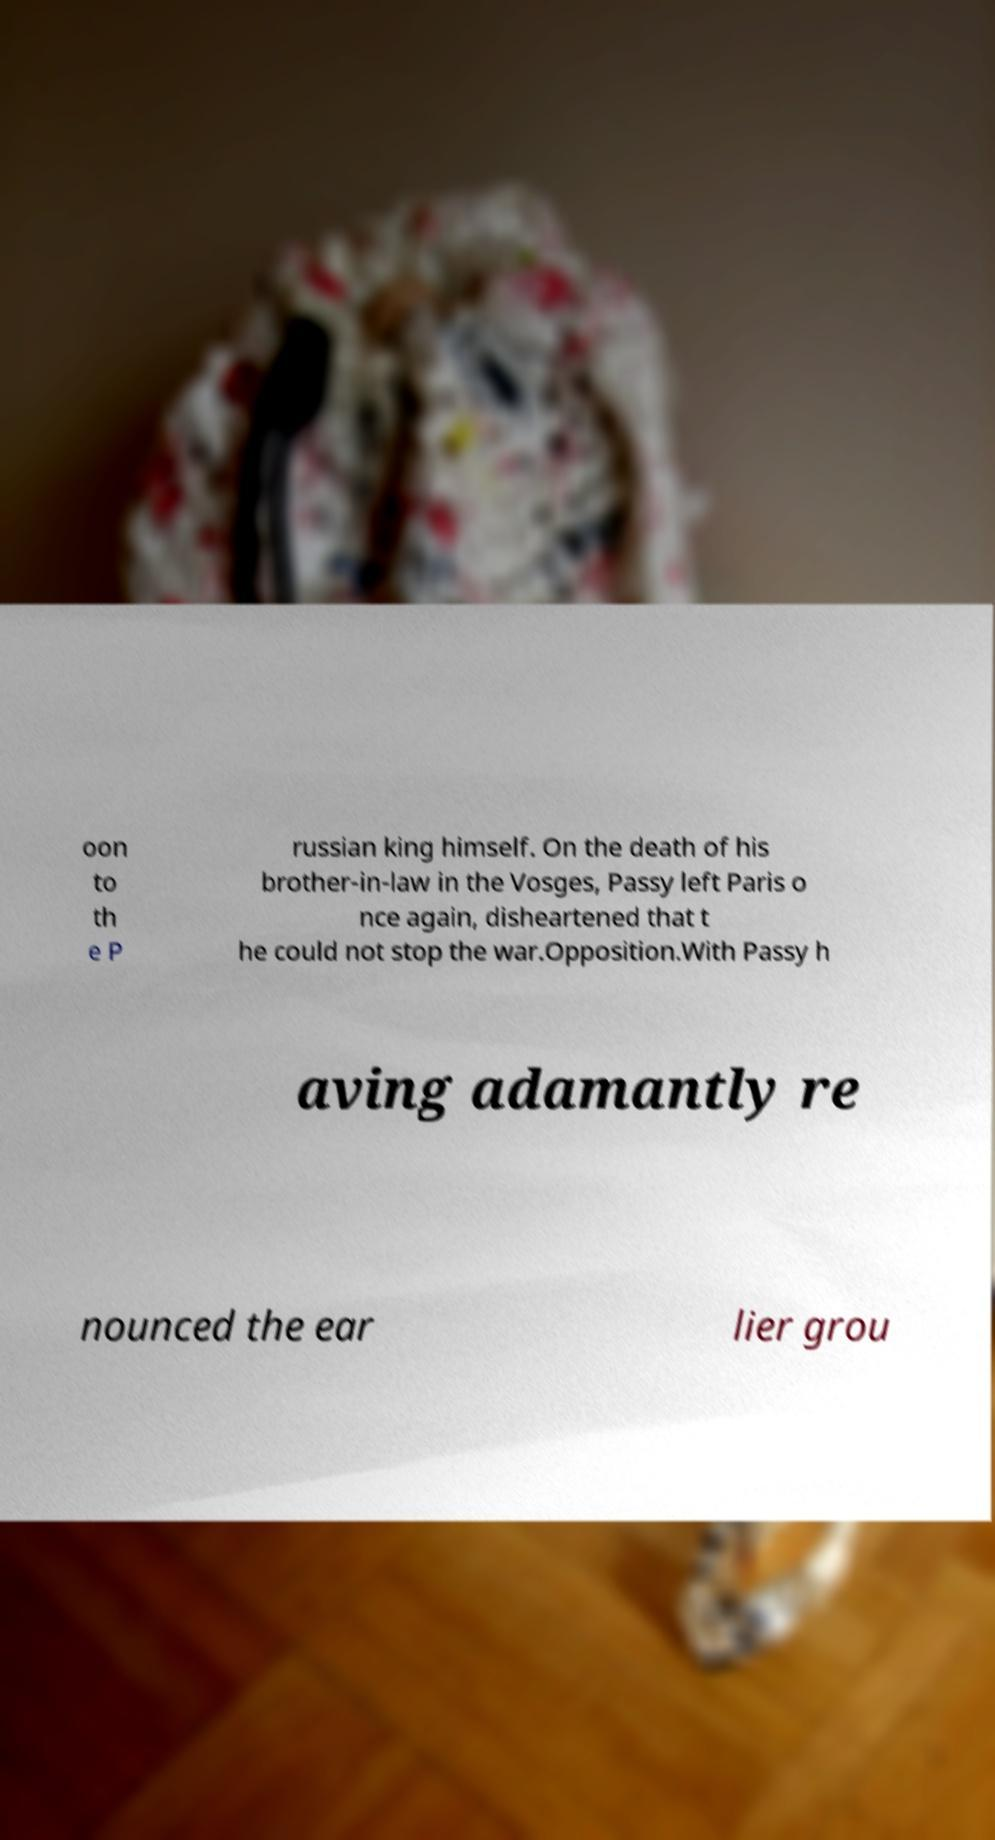Could you assist in decoding the text presented in this image and type it out clearly? oon to th e P russian king himself. On the death of his brother-in-law in the Vosges, Passy left Paris o nce again, disheartened that t he could not stop the war.Opposition.With Passy h aving adamantly re nounced the ear lier grou 